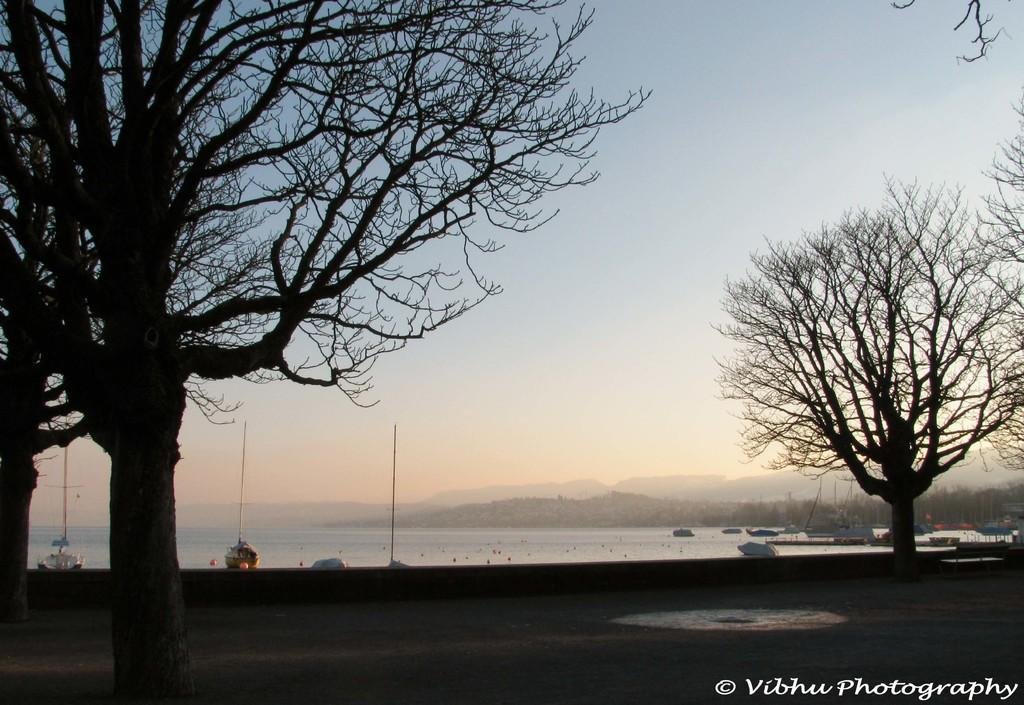What is the main feature of the image? There is a road in the image. What can be seen alongside the road? Trees are present along the road. What else is visible in the image besides the road and trees? There is water, poles, a hill, and the sky visible in the image. What is the text at the bottom of the image? The provided facts do not mention the content of the text at the bottom of the image. Can you see a giraffe walking along the road in the image? No, there is no giraffe present in the image. What is the source of shame for the people in the image? There are no people or any indication of shame in the image. 